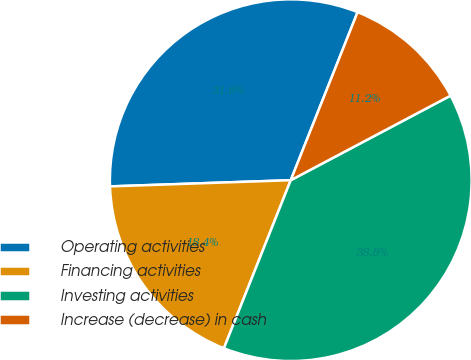Convert chart to OTSL. <chart><loc_0><loc_0><loc_500><loc_500><pie_chart><fcel>Operating activities<fcel>Financing activities<fcel>Investing activities<fcel>Increase (decrease) in cash<nl><fcel>31.57%<fcel>18.43%<fcel>38.77%<fcel>11.23%<nl></chart> 